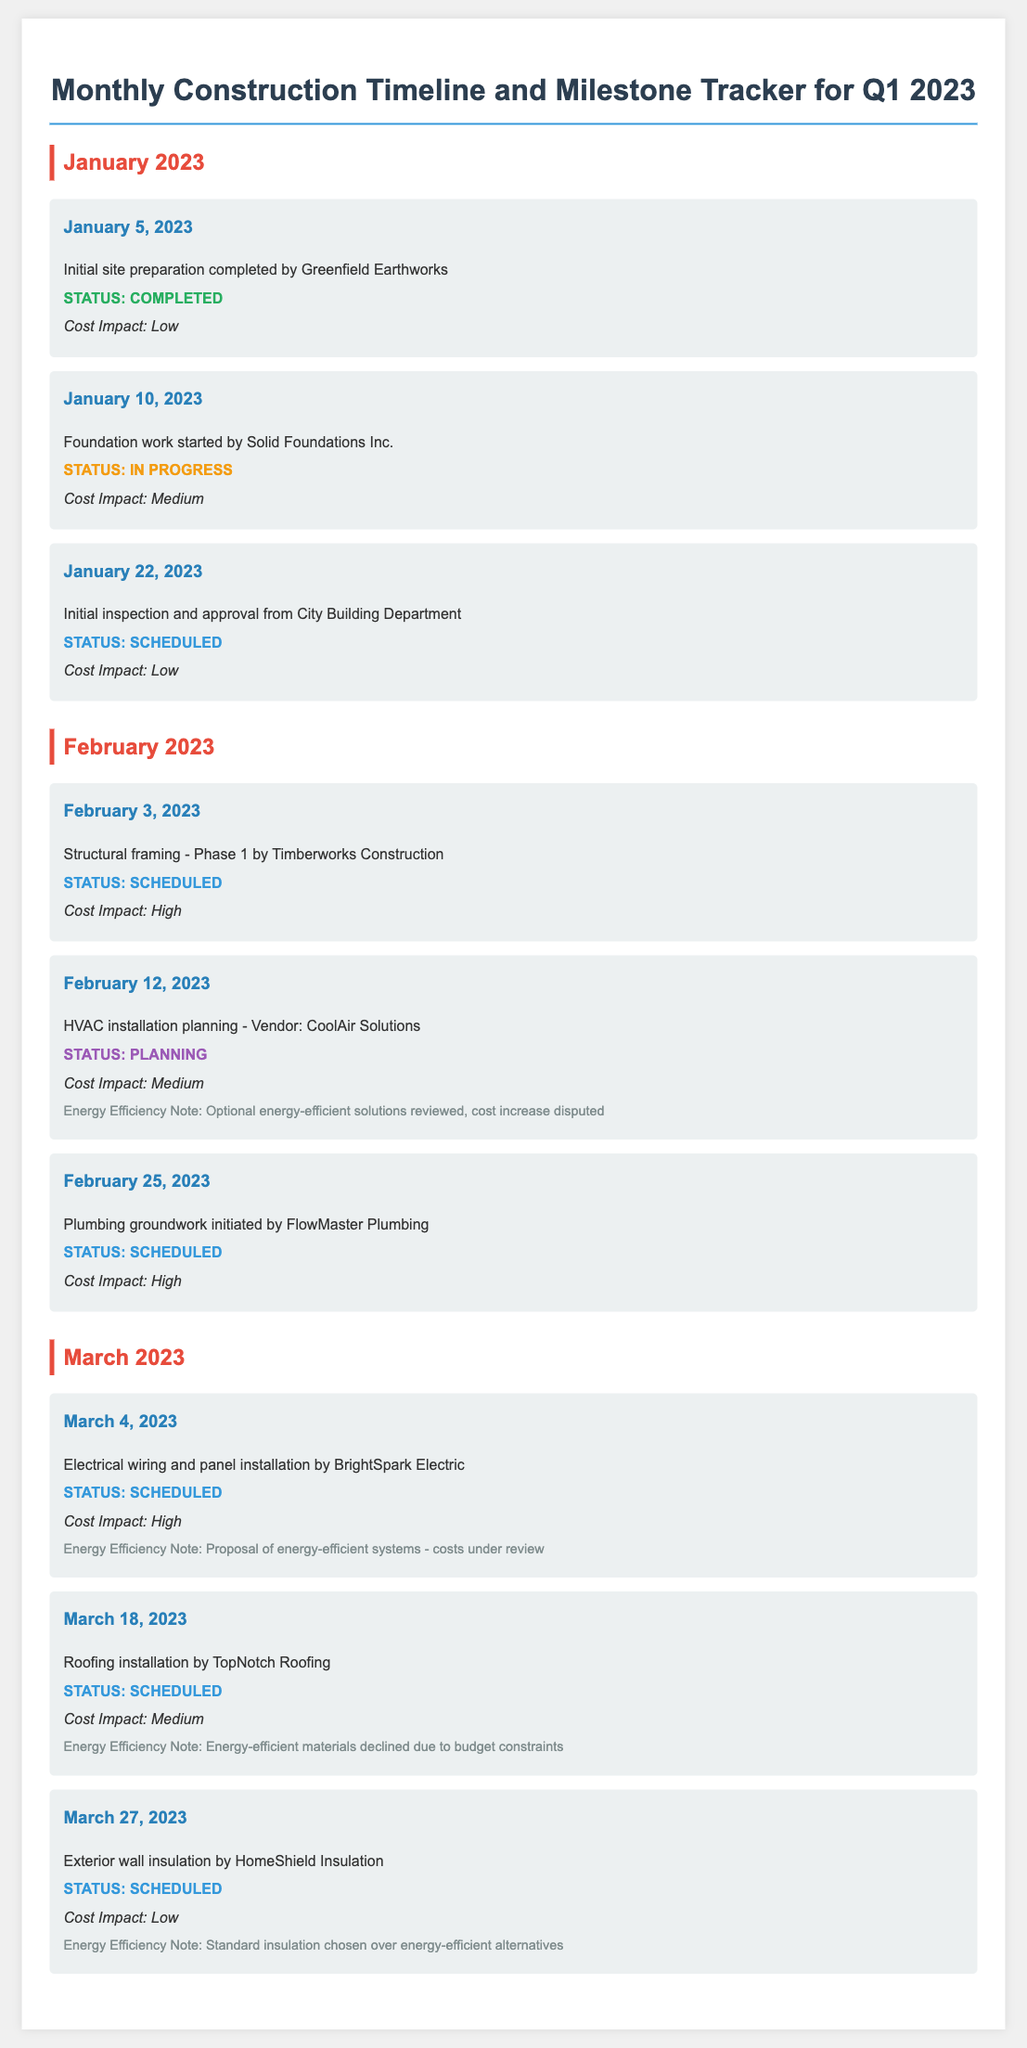What is the first milestone listed for January 2023? The first milestone listed for January 2023 is the initial site preparation completed by Greenfield Earthworks on January 5, 2023.
Answer: Initial site preparation completed by Greenfield Earthworks What is the status of HVAC installation planning in February 2023? The status of HVAC installation planning by CoolAir Solutions is noted as "Planning."
Answer: Planning How many milestones are scheduled for March 2023? There are three milestones scheduled for March 2023.
Answer: Three What is the cost impact of plumbing groundwork initiated in February 2023? The cost impact of plumbing groundwork initiated by FlowMaster Plumbing on February 25, 2023, is "High."
Answer: High What energy efficiency note is associated with roofing installation in March 2023? The energy efficiency note states that energy-efficient materials were declined due to budget constraints during roofing installation.
Answer: Energy-efficient materials declined due to budget constraints What company is responsible for the structural framing in February 2023? The company responsible for the structural framing in February 2023 is Timberworks Construction.
Answer: Timberworks Construction What date is the initial inspection from the City Building Department scheduled for? The initial inspection and approval from the City Building Department is scheduled for January 22, 2023.
Answer: January 22, 2023 What is the status of electrical wiring installation in March 2023? The status of electrical wiring and panel installation by BrightSpark Electric is "Scheduled."
Answer: Scheduled 